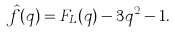Convert formula to latex. <formula><loc_0><loc_0><loc_500><loc_500>\hat { f } ( q ) = F _ { L } ( q ) - 3 q ^ { 2 } - 1 .</formula> 